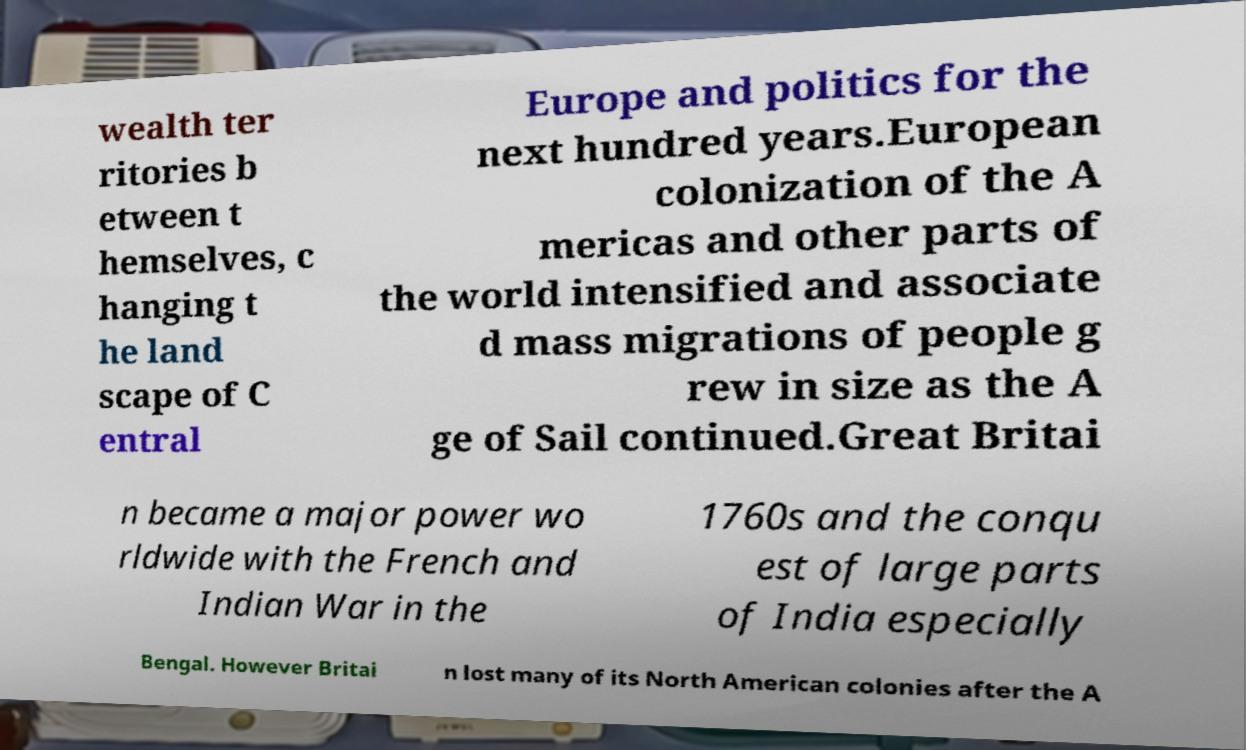What messages or text are displayed in this image? I need them in a readable, typed format. wealth ter ritories b etween t hemselves, c hanging t he land scape of C entral Europe and politics for the next hundred years.European colonization of the A mericas and other parts of the world intensified and associate d mass migrations of people g rew in size as the A ge of Sail continued.Great Britai n became a major power wo rldwide with the French and Indian War in the 1760s and the conqu est of large parts of India especially Bengal. However Britai n lost many of its North American colonies after the A 